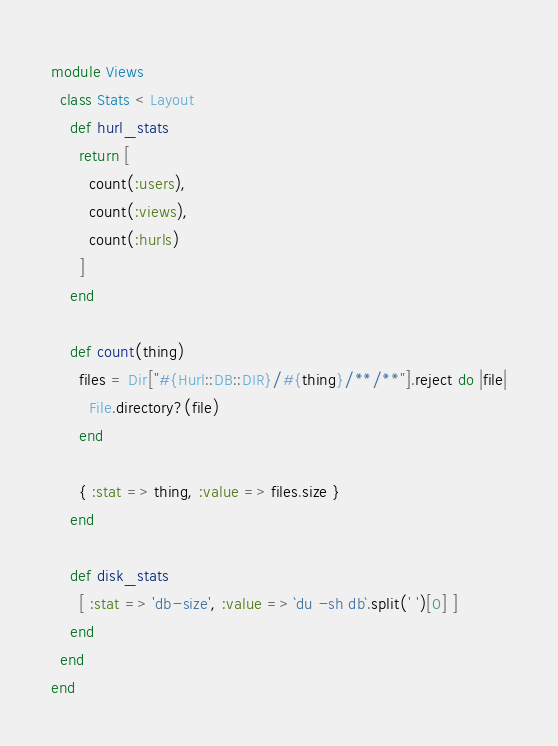<code> <loc_0><loc_0><loc_500><loc_500><_Ruby_>module Views
  class Stats < Layout
    def hurl_stats
      return [
        count(:users),
        count(:views),
        count(:hurls)
      ]
    end

    def count(thing)
      files = Dir["#{Hurl::DB::DIR}/#{thing}/**/**"].reject do |file|
        File.directory?(file)
      end

      { :stat => thing, :value => files.size }
    end

    def disk_stats
      [ :stat => 'db-size', :value => `du -sh db`.split(' ')[0] ]
    end
  end
end
</code> 